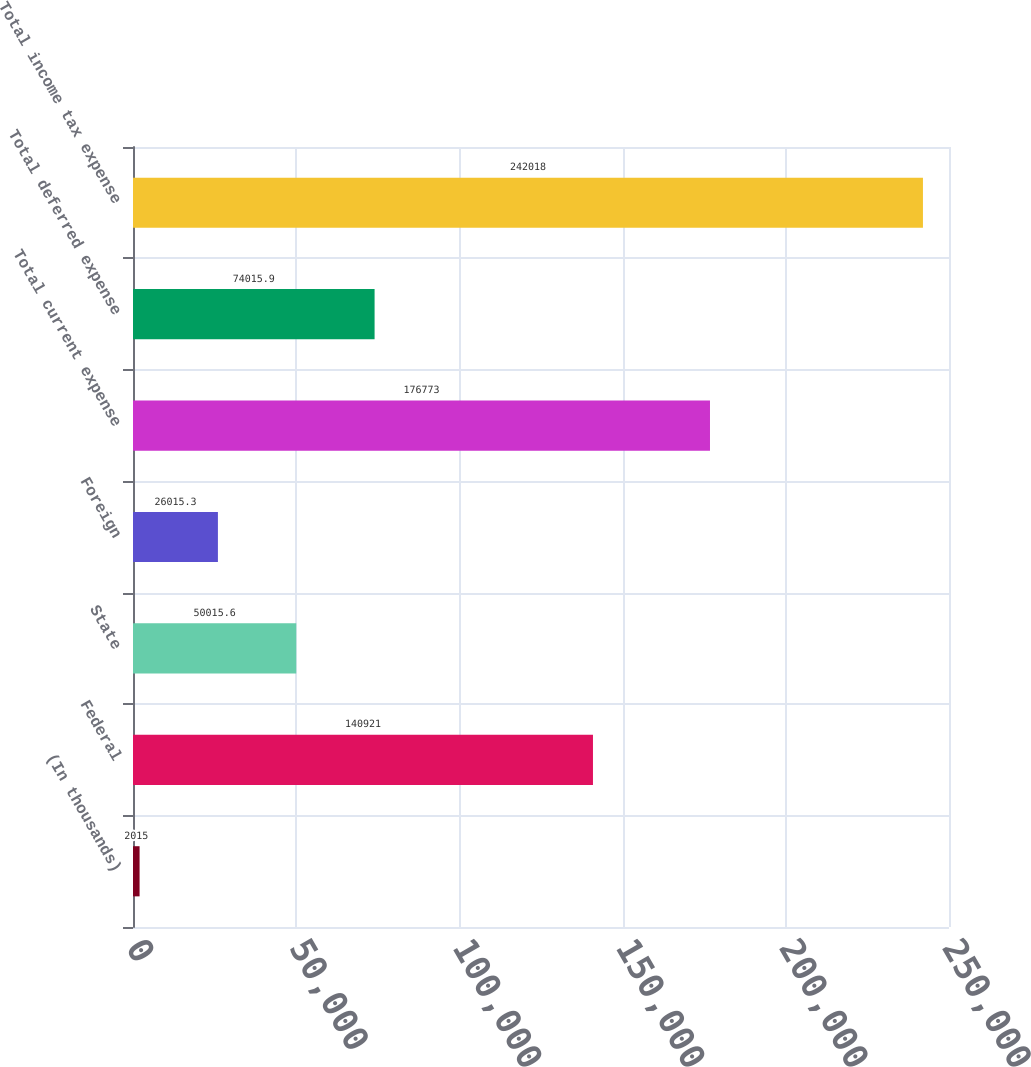Convert chart to OTSL. <chart><loc_0><loc_0><loc_500><loc_500><bar_chart><fcel>(In thousands)<fcel>Federal<fcel>State<fcel>Foreign<fcel>Total current expense<fcel>Total deferred expense<fcel>Total income tax expense<nl><fcel>2015<fcel>140921<fcel>50015.6<fcel>26015.3<fcel>176773<fcel>74015.9<fcel>242018<nl></chart> 